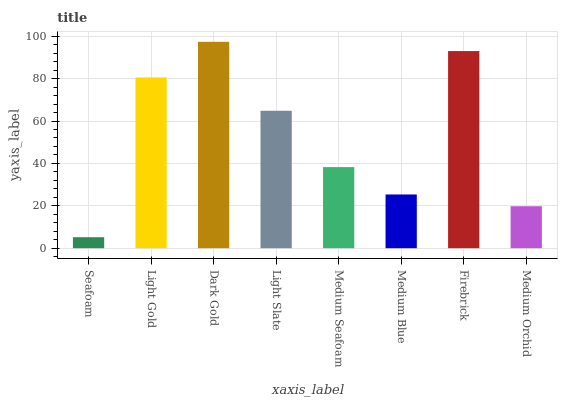Is Seafoam the minimum?
Answer yes or no. Yes. Is Dark Gold the maximum?
Answer yes or no. Yes. Is Light Gold the minimum?
Answer yes or no. No. Is Light Gold the maximum?
Answer yes or no. No. Is Light Gold greater than Seafoam?
Answer yes or no. Yes. Is Seafoam less than Light Gold?
Answer yes or no. Yes. Is Seafoam greater than Light Gold?
Answer yes or no. No. Is Light Gold less than Seafoam?
Answer yes or no. No. Is Light Slate the high median?
Answer yes or no. Yes. Is Medium Seafoam the low median?
Answer yes or no. Yes. Is Seafoam the high median?
Answer yes or no. No. Is Light Gold the low median?
Answer yes or no. No. 